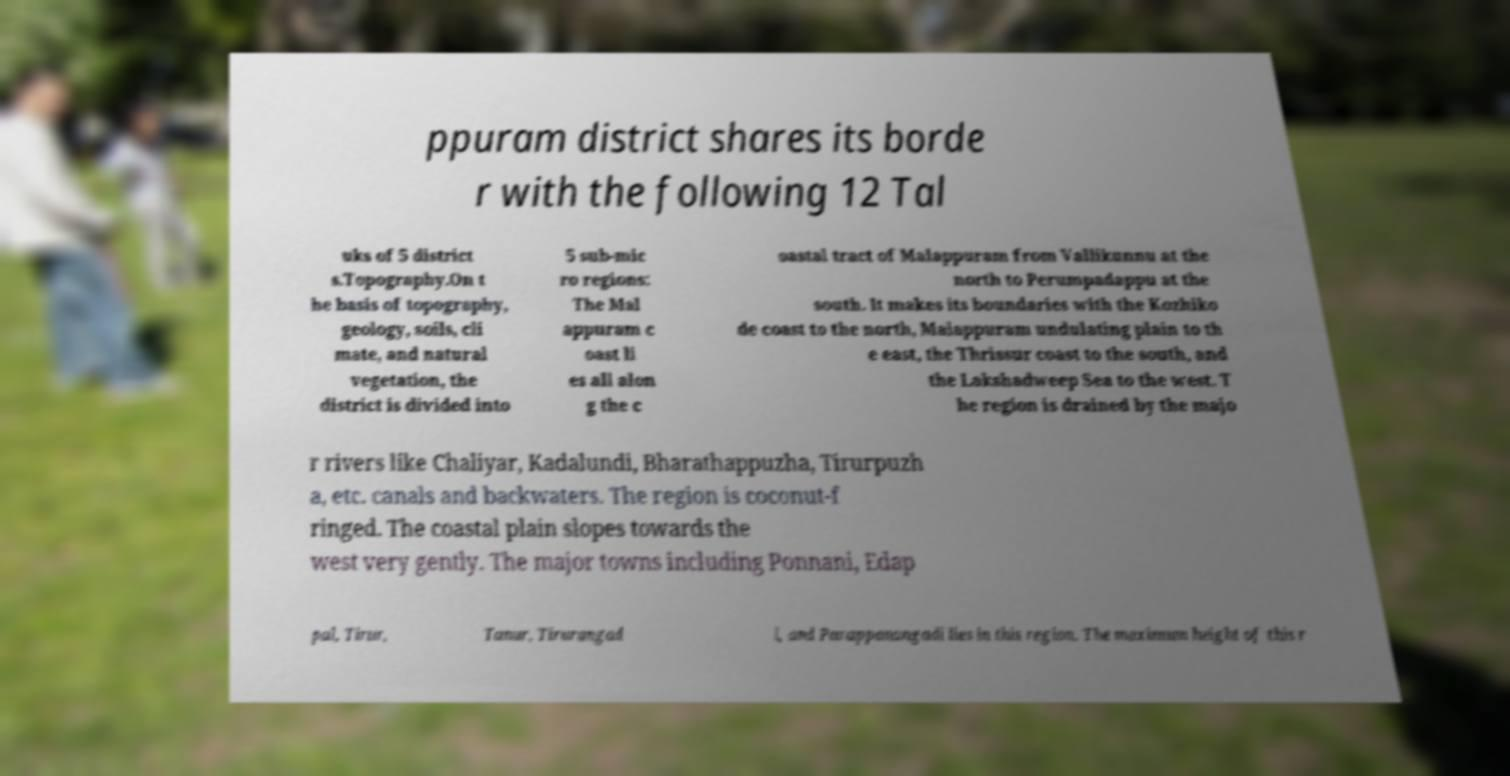Could you extract and type out the text from this image? ppuram district shares its borde r with the following 12 Tal uks of 5 district s.Topography.On t he basis of topography, geology, soils, cli mate, and natural vegetation, the district is divided into 5 sub-mic ro regions: The Mal appuram c oast li es all alon g the c oastal tract of Malappuram from Vallikunnu at the north to Perumpadappu at the south. It makes its boundaries with the Kozhiko de coast to the north, Malappuram undulating plain to th e east, the Thrissur coast to the south, and the Lakshadweep Sea to the west. T he region is drained by the majo r rivers like Chaliyar, Kadalundi, Bharathappuzha, Tirurpuzh a, etc. canals and backwaters. The region is coconut-f ringed. The coastal plain slopes towards the west very gently. The major towns including Ponnani, Edap pal, Tirur, Tanur, Tirurangad i, and Parappanangadi lies in this region. The maximum height of this r 